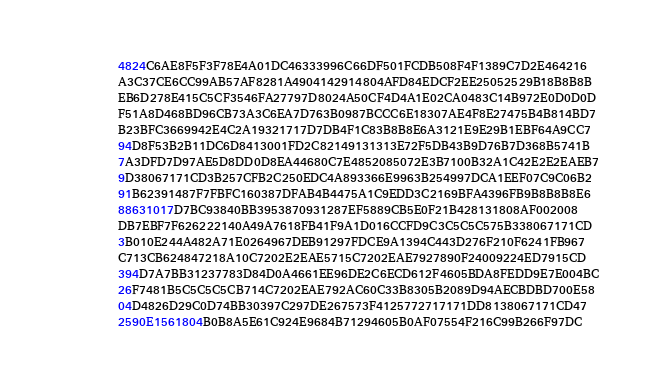Convert code to text. <code><loc_0><loc_0><loc_500><loc_500><_Pascal_>          4824C6AE8F5F3F78E4A01DC46333996C66DF501FCDB508F4F1389C7D2E464216
          A3C37CE6CC99AB57AF8281A4904142914804AFD84EDCF2EE25052529B18B8B8B
          EB6D278E415C5CF3546FA27797D8024A50CF4D4A1E02CA0483C14B972E0D0D0D
          F51A8D468BD96CB73A3C6EA7D763B0987BCCC6E18307AE4F8E27475B4B814BD7
          B23BFC3669942E4C2A19321717D7DB4F1C83B8B8E6A3121E9E29B1EBF64A9CC7
          94D8F53B2B11DC6D8413001FD2C82149131313E72F5DB43B9D76B7D368B5741B
          7A3DFD7D97AE5D8DD0D8EA44680C7E4852085072E3B7100B32A1C42E2E2EAEB7
          9D38067171CD3B257CFB2C250EDC4A893366E9963B254997DCA1EEF07C9C06B2
          91B62391487F7FBFC160387DFAB4B4475A1C9EDD3C2169BFA4396FB9B8B8B8E6
          88631017D7BC93840BB3953870931287EF5889CB5E0F21B428131808AF002008
          DB7EBF7F626222140A49A7618FB41F9A1D016CCFD9C3C5C5C575B338067171CD
          3B010E244A482A71E0264967DEB91297FDCE9A1394C443D276F210F6241FB967
          C713CB624847218A10C7202E2EAE5715C7202EAE7927890F24009224ED7915CD
          394D7A7BB31237783D84D0A4661EE96DE2C6ECD612F4605BDA8FEDD9E7E004BC
          26F7481B5C5C5C5CB714C7202EAE792AC60C33B8305B2089D94AECBDBD700E58
          04D4826D29C0D74BB30397C297DE267573F4125772717171DD8138067171CD47
          2590E1561804B0B8A5E61C924E9684B71294605B0AF07554F216C99B266F97DC</code> 